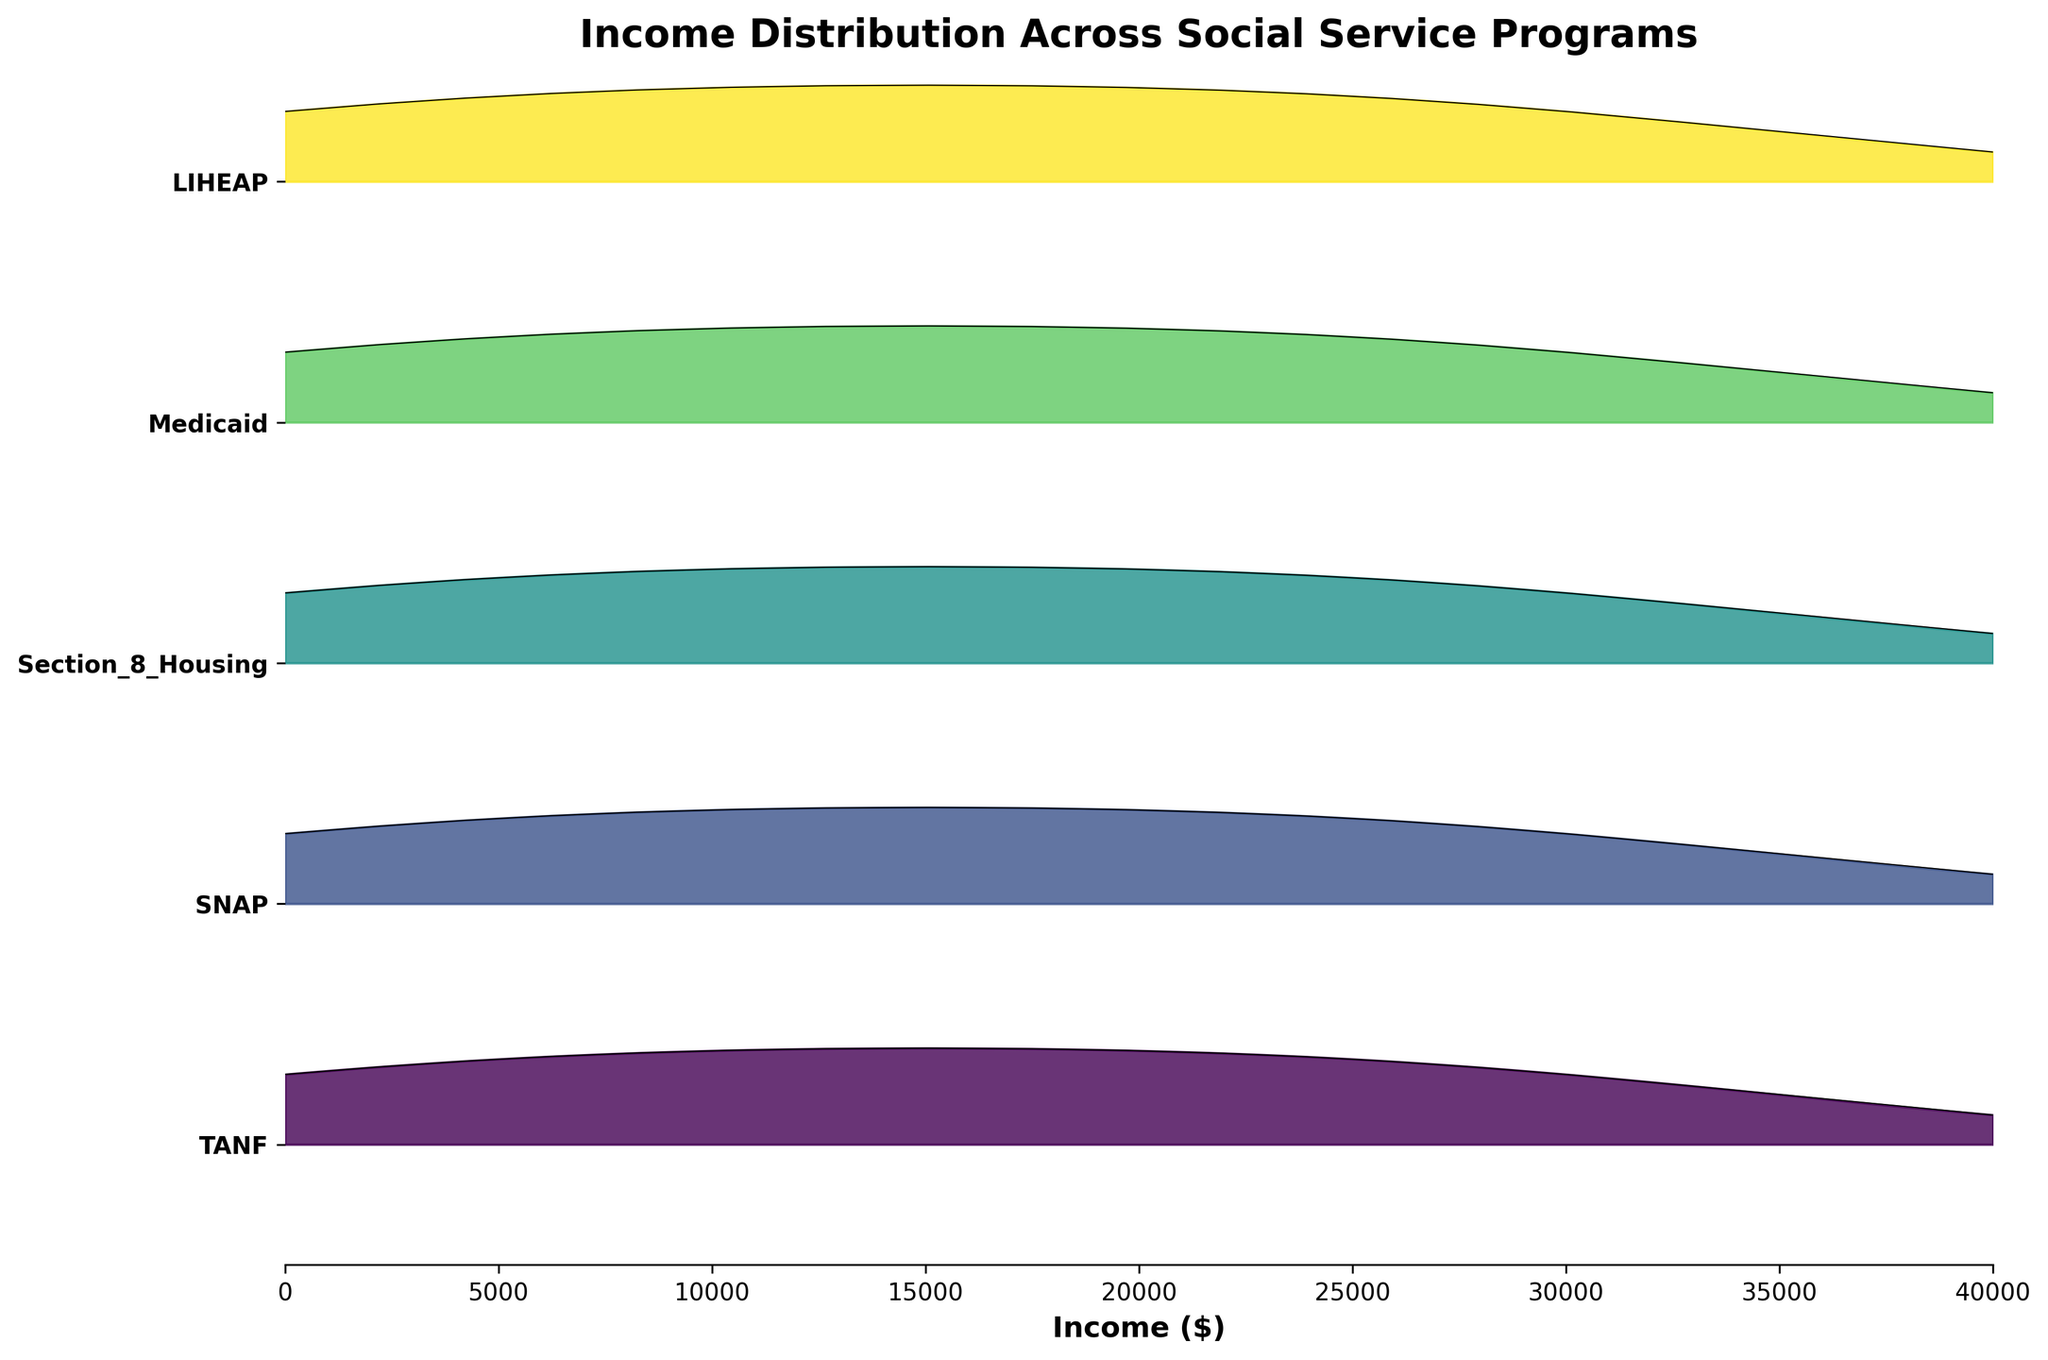What is the title of the plot? The title of the plot is located at the top center of the figure. It helps in understanding what the plot is about. The title is "Income Distribution Across Social Service Programs."
Answer: Income Distribution Across Social Service Programs Which program has the highest density in the income bracket of $0-$10,000? Look at the peak of the distributions for different programs within the income bracket of $0-$10,000. The program with the highest density peak in this range is LIHEAP.
Answer: LIHEAP How do the income distributions of TANF and SNAP compare? Compare the ridgelines of TANF and SNAP across the income brackets. Both TANF and SNAP have their highest densities in the $10,001-$20,000 bracket, but TANF has a slightly higher density in the $0-$10,000 bracket than SNAP.
Answer: TANF has a slightly higher density in the $0-$10,000 bracket compared to SNAP Which income bracket shows the highest concentration of people across all programs? Observe the density distributions of all programs. Find the income bracket where most programs show their peaks or high densities. The $10,001-$20,000 income bracket shows the highest concentration for most programs.
Answer: $10,001-$20,000 What is the relative position of the Medicaid program in terms of density in the $20,001-$30,000 income bracket compared to Section 8 Housing? Compare the densities of the Medicaid and Section 8 Housing programs within the $20,001-$30,000 income bracket. Both programs have similar densities, but Section 8 Housing has a slightly higher peak.
Answer: Section 8 Housing has a slightly higher peak Which program has the widest spread in income distribution? The program with the widest spread will have a broader and possibly less peaked distribution. TANF and Medicaid show broader distributions across all income brackets compared to others.
Answer: TANF and Medicaid 